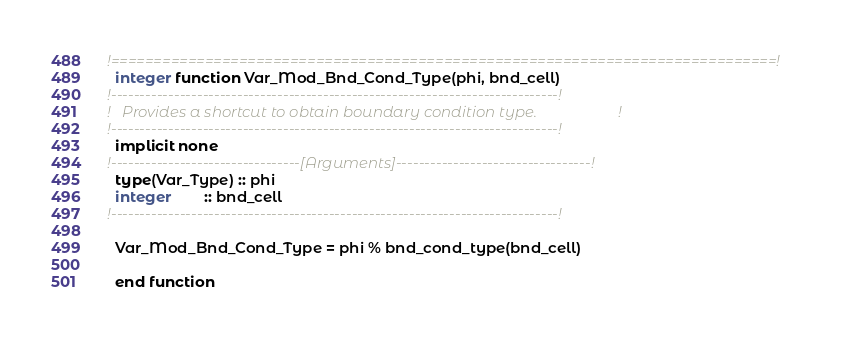Convert code to text. <code><loc_0><loc_0><loc_500><loc_500><_FORTRAN_>!==============================================================================!
  integer function Var_Mod_Bnd_Cond_Type(phi, bnd_cell)
!------------------------------------------------------------------------------!
!   Provides a shortcut to obtain boundary condition type.                     !
!------------------------------------------------------------------------------!
  implicit none
!---------------------------------[Arguments]----------------------------------!
  type(Var_Type) :: phi
  integer        :: bnd_cell
!------------------------------------------------------------------------------!

  Var_Mod_Bnd_Cond_Type = phi % bnd_cond_type(bnd_cell)

  end function

</code> 